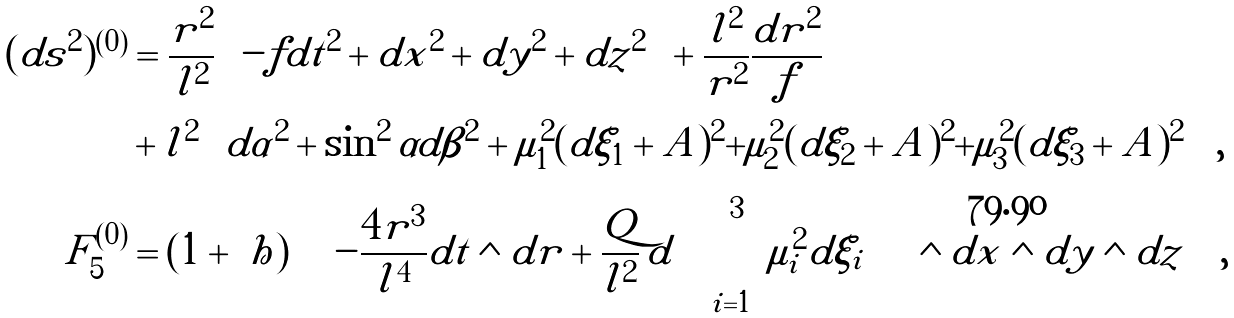<formula> <loc_0><loc_0><loc_500><loc_500>( d s ^ { 2 } ) ^ { ( 0 ) } & = \frac { r ^ { 2 } } { l ^ { 2 } } \left ( - f d t ^ { 2 } + d x ^ { 2 } + d y ^ { 2 } + d z ^ { 2 } \right ) + \frac { l ^ { 2 } } { r ^ { 2 } } \frac { d r ^ { 2 } } { f } \\ & + l ^ { 2 } \left ( d \alpha ^ { 2 } + \sin ^ { 2 } \alpha d \beta ^ { 2 } + \mu _ { 1 } ^ { 2 } ( d \xi _ { 1 } + A ) ^ { 2 } + \mu _ { 2 } ^ { 2 } ( d \xi _ { 2 } + A ) ^ { 2 } + \mu _ { 3 } ^ { 2 } ( d \xi _ { 3 } + A ) ^ { 2 } \right ) \, , \\ F _ { 5 } ^ { ( 0 ) } & = ( 1 + \ h ) \left [ \left ( - \frac { 4 r ^ { 3 } } { l ^ { 4 } } d t \wedge d r + \frac { Q } { l ^ { 2 } } \, d \left ( \sum _ { i = 1 } ^ { 3 } \mu _ { i } ^ { 2 } d \xi _ { i } \right ) \right ) \wedge d x \wedge d y \wedge d z \right ] \, ,</formula> 